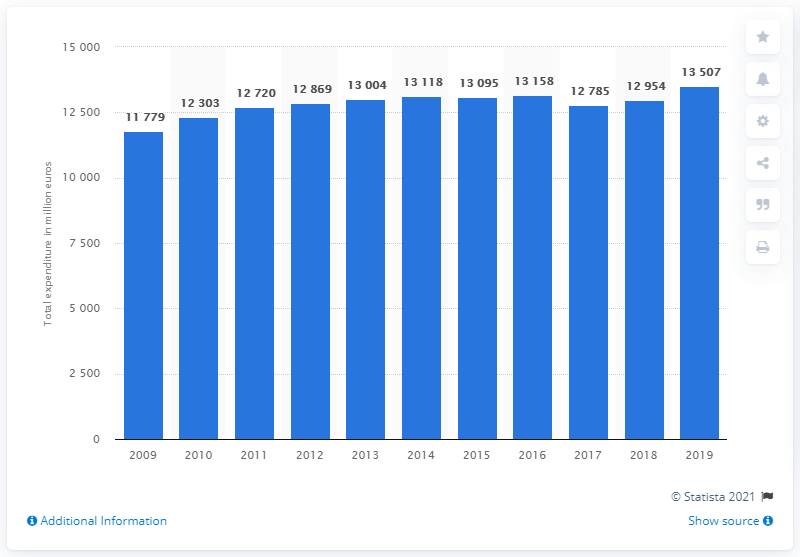Specify some key components in this picture. In 2014, Finland's education spending stopped increasing. In 2019, the education spending in Finland was 13,507. 